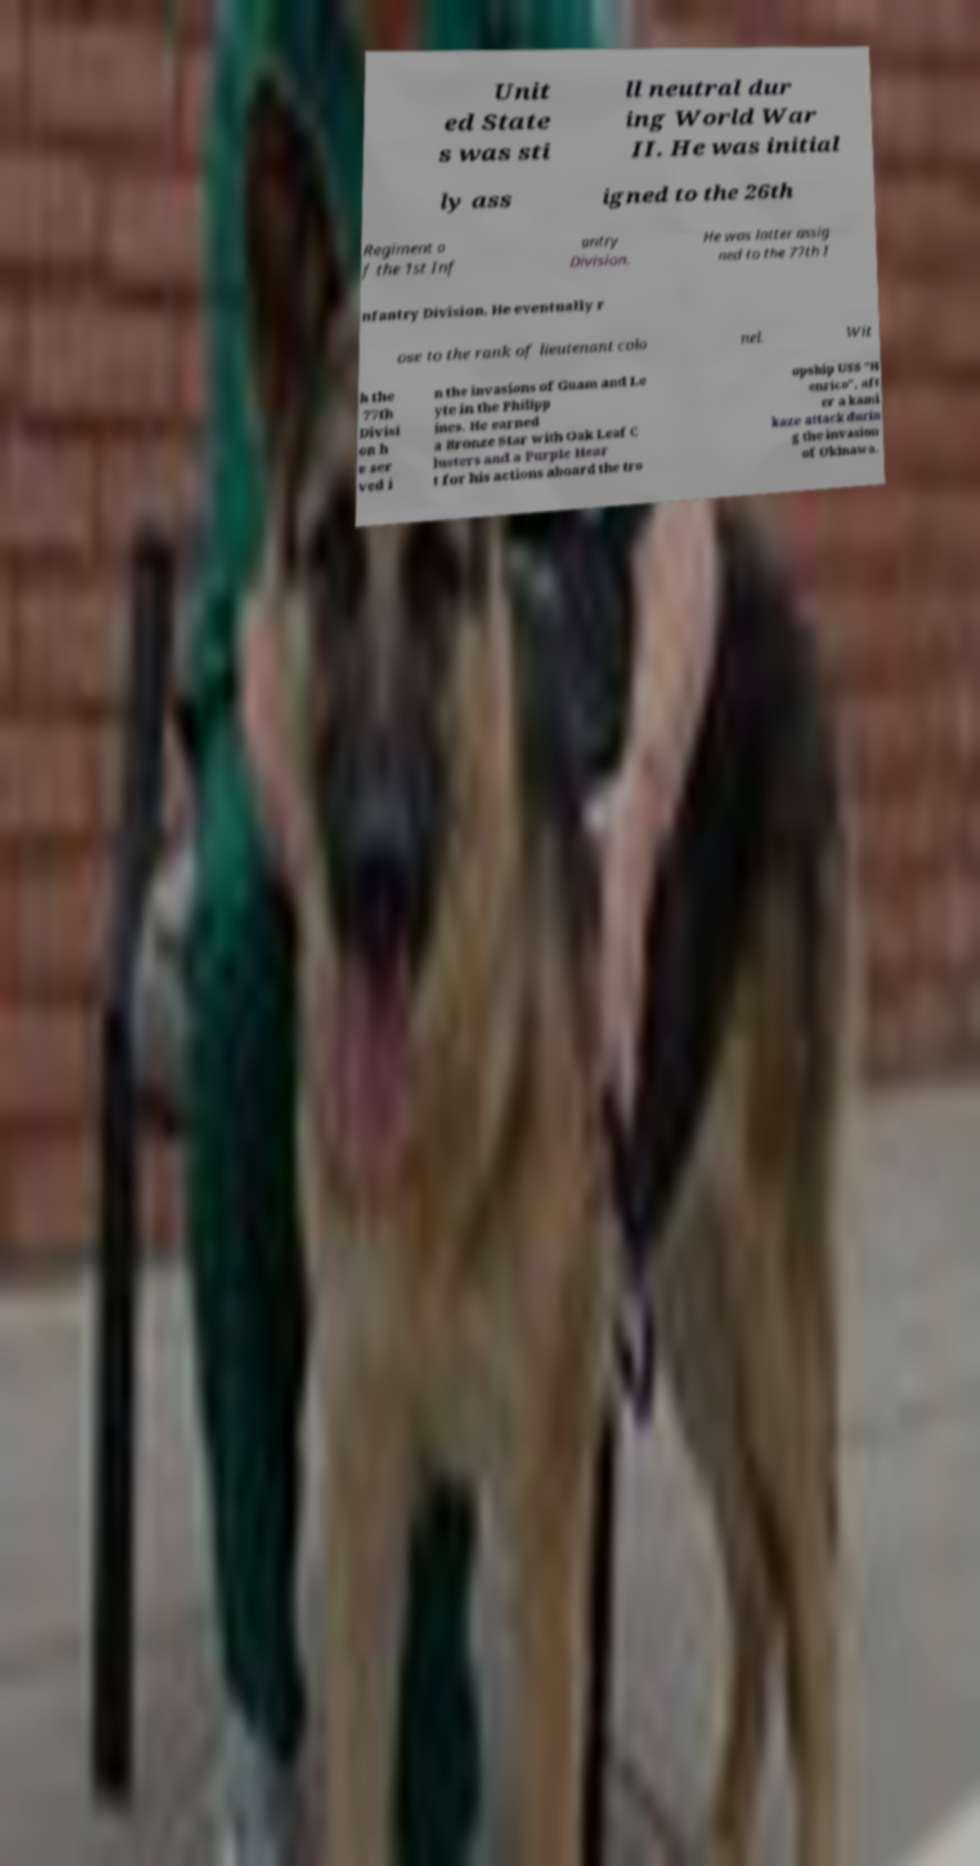I need the written content from this picture converted into text. Can you do that? Unit ed State s was sti ll neutral dur ing World War II. He was initial ly ass igned to the 26th Regiment o f the 1st Inf antry Division. He was latter assig ned to the 77th I nfantry Division. He eventually r ose to the rank of lieutenant colo nel. Wit h the 77th Divisi on h e ser ved i n the invasions of Guam and Le yte in the Philipp ines. He earned a Bronze Star with Oak Leaf C lusters and a Purple Hear t for his actions aboard the tro opship USS "H enrico", aft er a kami kaze attack durin g the invasion of Okinawa. 